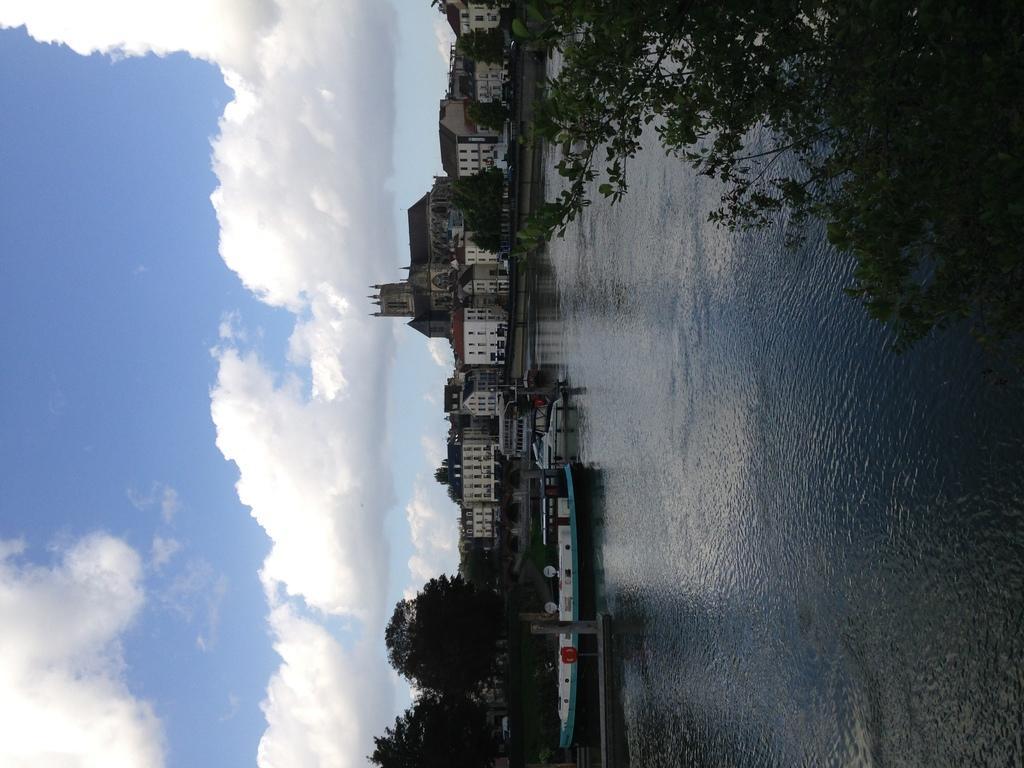Can you describe this image briefly? This image is taken outdoors. On the left side of the image there is a sky with clouds. In the middle of the image there are many buildings, houses, trees and plants. On the right side of the image there is a tree and a river with water and a boat in it. 